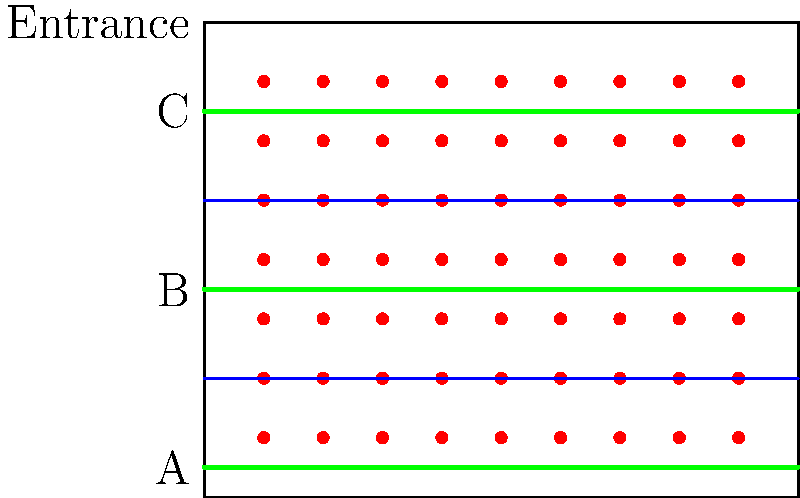In the concert hall layout shown above, three possible paths (A, B, and C) are marked for ushers to navigate through the aisles. Given that the hall is $10$ meters wide and $8$ meters deep, with two main aisles dividing the seating area into three sections, which path would be most efficient for ushers to use when guiding late arrivals to their seats? Assume that all seats are equally likely to be occupied. To determine the most efficient path, we need to consider the coverage and accessibility of each path:

1. Calculate the total seating area:
   Total area = $10m \times 8m = 80m^2$

2. Calculate the area covered by each section:
   Section area = $80m^2 \div 3 \approx 26.67m^2$

3. Analyze each path:
   Path A: Covers the bottom section
   Path B: Covers the middle section
   Path C: Covers the top section

4. Consider the proximity to the entrance:
   Path C is closest to the entrance, followed by Path B, then Path A.

5. Evaluate efficiency:
   - Path B is in the middle, providing easy access to both upper and lower sections.
   - It covers approximately 1/3 of the seating area directly.
   - It allows quick movement to either the upper or lower section if needed.

6. Consider audience disruption:
   Path B would cause the least disruption as it's between two sections, minimizing the number of seated patrons the usher needs to pass.

7. Conclusion:
   Path B is the most efficient as it provides balanced coverage, easy access to all sections, and minimizes audience disruption.
Answer: Path B 